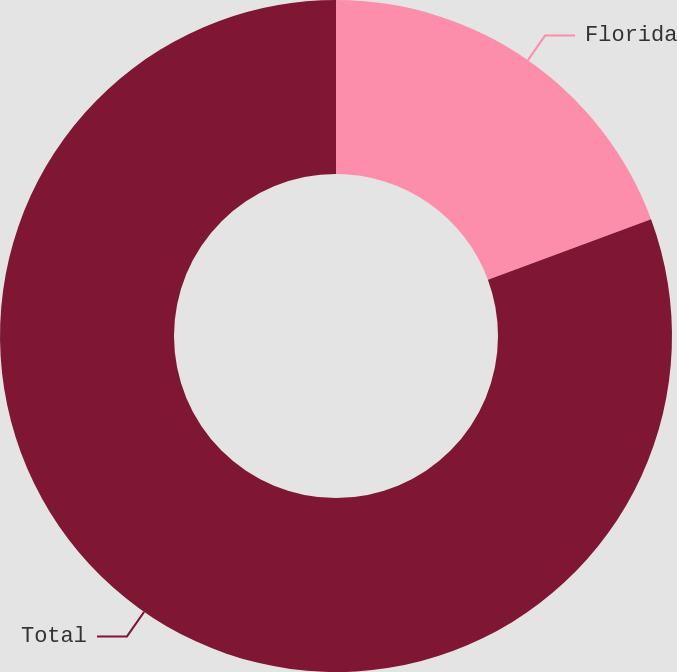Convert chart. <chart><loc_0><loc_0><loc_500><loc_500><pie_chart><fcel>Florida<fcel>Total<nl><fcel>19.35%<fcel>80.65%<nl></chart> 